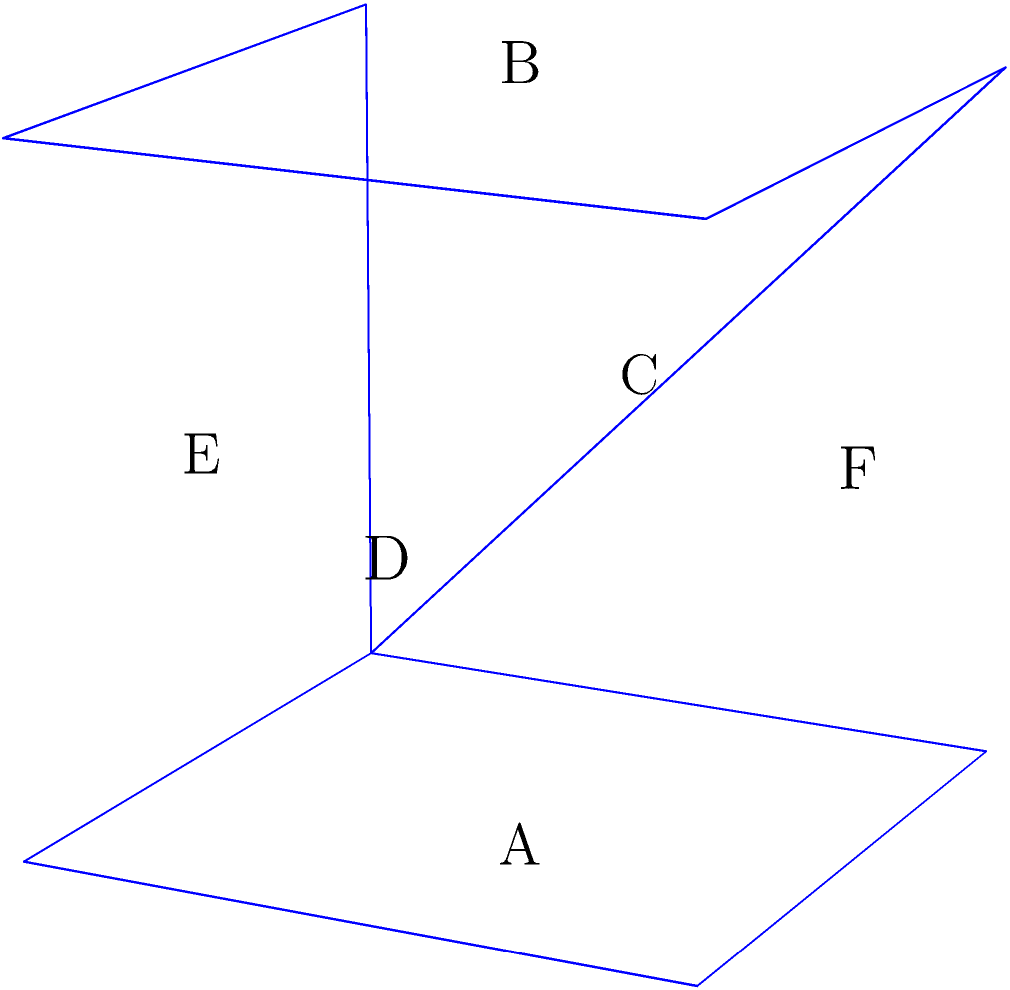As a mental health professional working with players to develop mental resilience, you're using spatial visualization exercises. Consider the cube shown above. If it is rotated 90 degrees clockwise around the vertical axis (as indicated by the arrow), which face will replace face D? To solve this problem, we need to mentally rotate the cube and visualize its new orientation. Let's break it down step-by-step:

1. Identify the current orientation:
   - Face A is on the bottom
   - Face B is on the top
   - Face C is on the left
   - Face D is on the right
   - Face E is on the front
   - Face F is on the back

2. Understand the rotation:
   - The cube will rotate 90 degrees clockwise around the vertical axis
   - This means faces A and B will remain in their positions (bottom and top)
   - The other faces will shift positions

3. Visualize the rotation:
   - Face C (left) will move to the front
   - Face E (front) will move to the right
   - Face D (right) will move to the back
   - Face F (back) will move to the left

4. Identify the new position of face D:
   - After rotation, face D will be at the back of the cube

5. Determine which face replaces D:
   - Face E, which was originally at the front, will now be on the right side, replacing face D

This spatial visualization exercise helps players develop their mental ability to manipulate objects in their mind, which can translate to better tactical decision-making and adaptability on the field.
Answer: E 